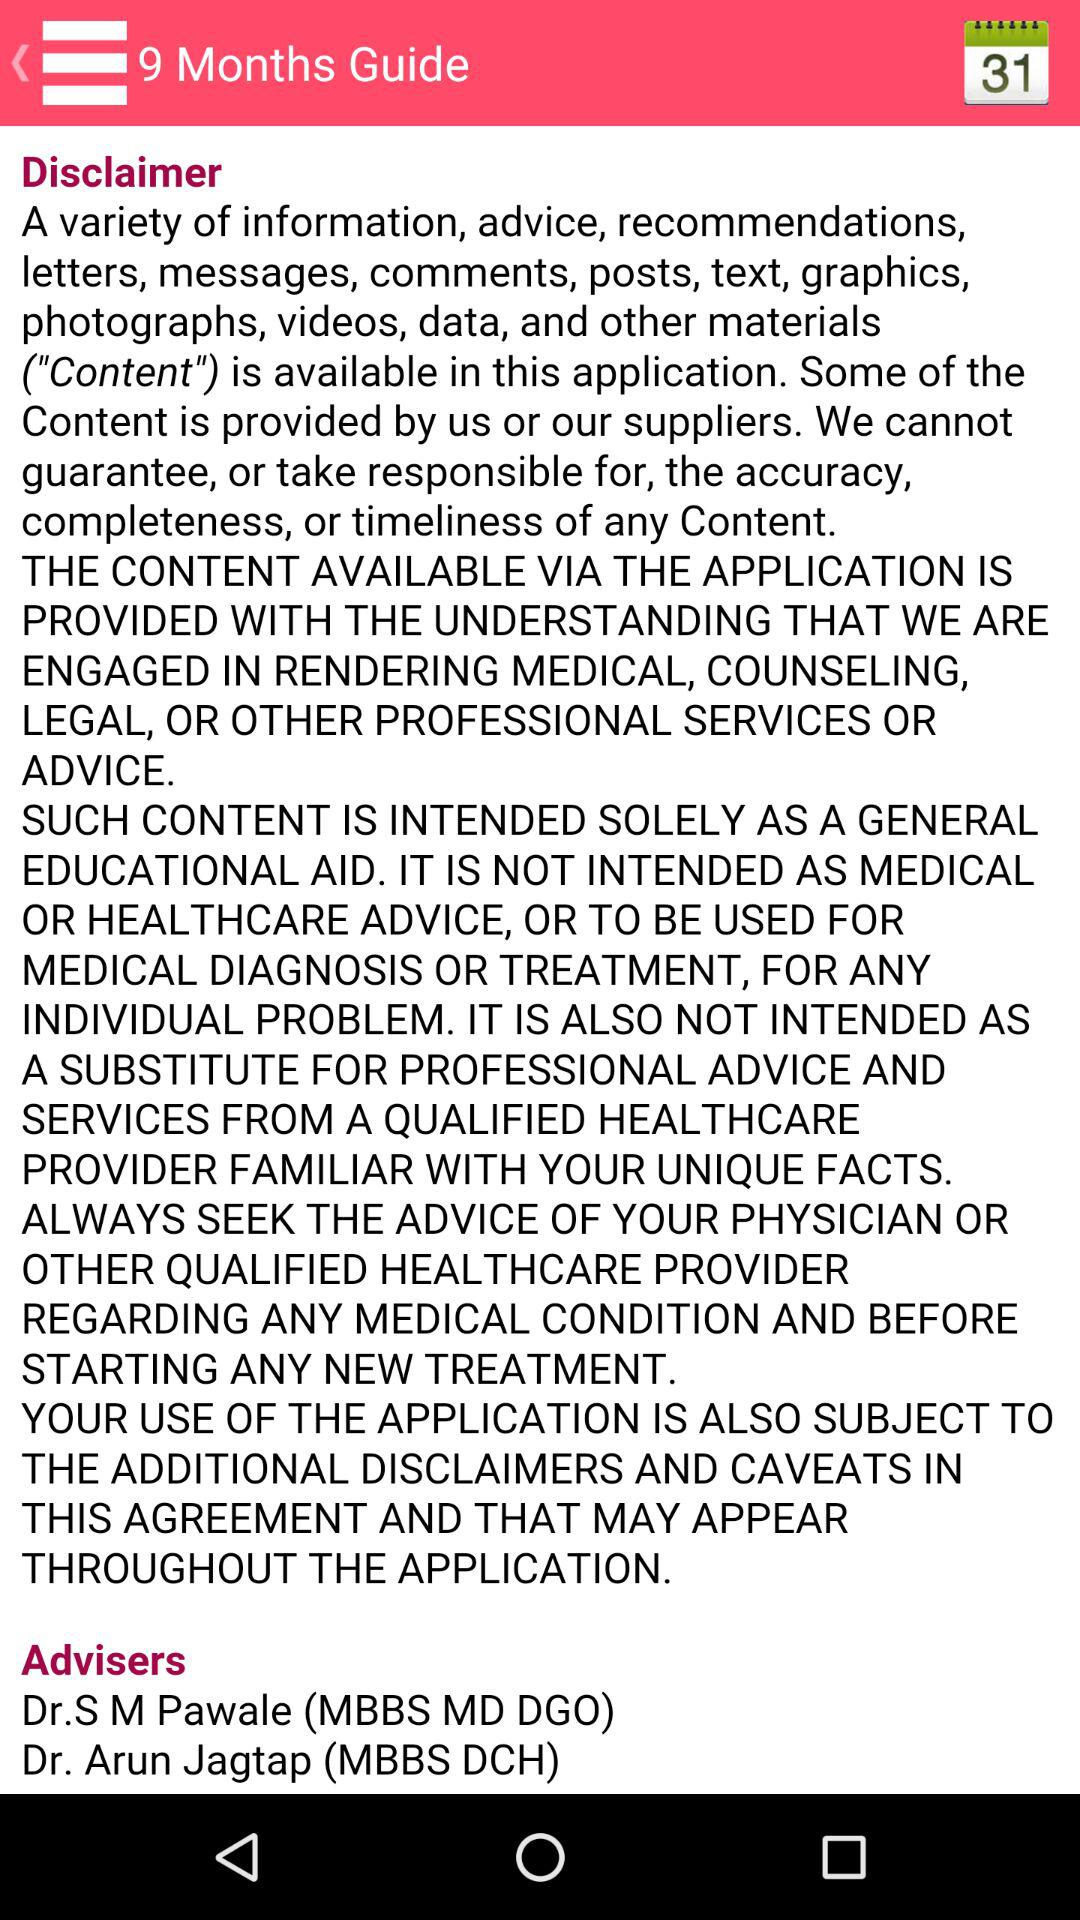What education degree does Dr. S M Pawale have? Dr. S. M. Pawale has an MBBS, MD, and DGO degree in education. 